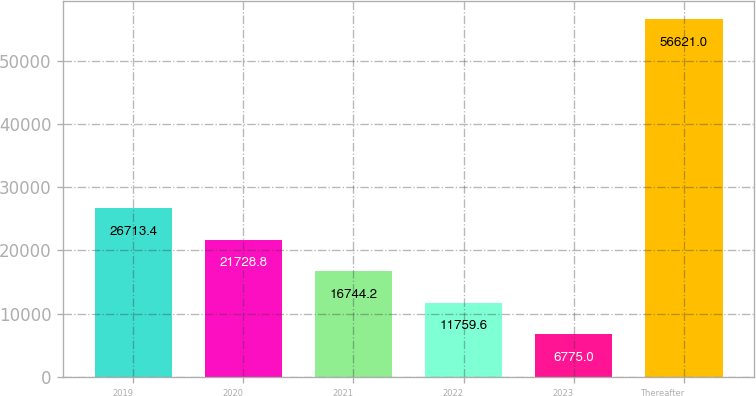<chart> <loc_0><loc_0><loc_500><loc_500><bar_chart><fcel>2019<fcel>2020<fcel>2021<fcel>2022<fcel>2023<fcel>Thereafter<nl><fcel>26713.4<fcel>21728.8<fcel>16744.2<fcel>11759.6<fcel>6775<fcel>56621<nl></chart> 